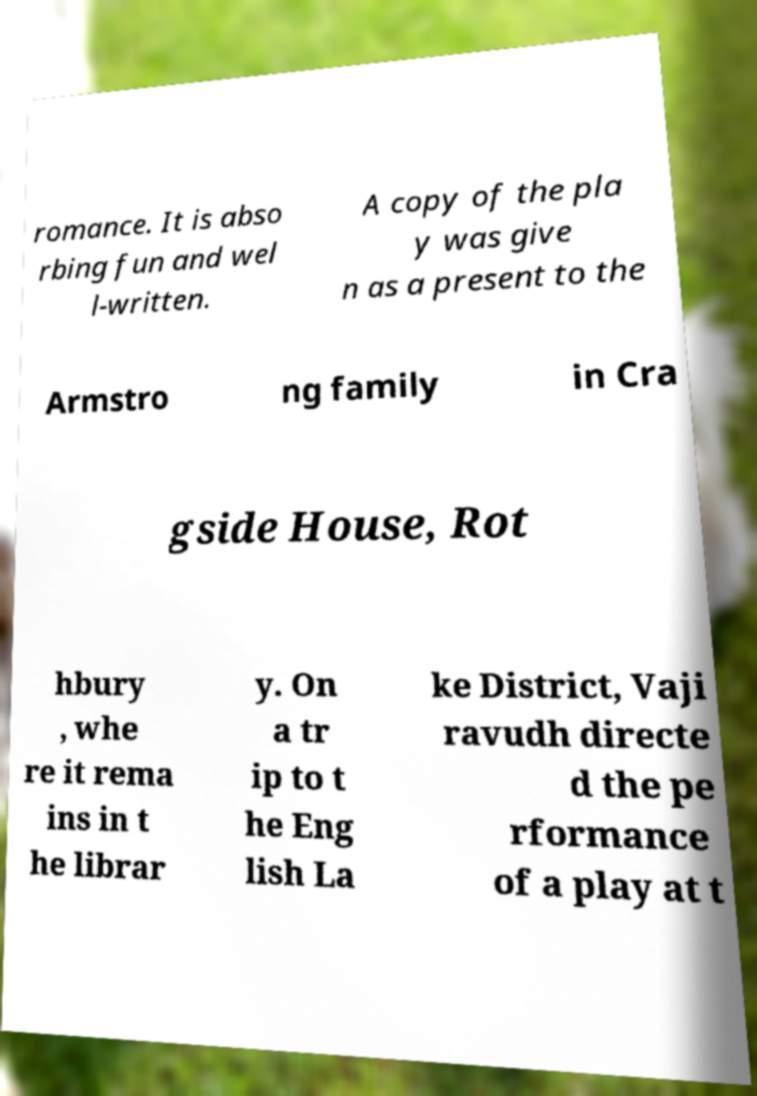Could you assist in decoding the text presented in this image and type it out clearly? romance. It is abso rbing fun and wel l-written. A copy of the pla y was give n as a present to the Armstro ng family in Cra gside House, Rot hbury , whe re it rema ins in t he librar y. On a tr ip to t he Eng lish La ke District, Vaji ravudh directe d the pe rformance of a play at t 